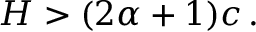<formula> <loc_0><loc_0><loc_500><loc_500>\begin{array} { r } { H > ( 2 \alpha + 1 ) c \, . } \end{array}</formula> 